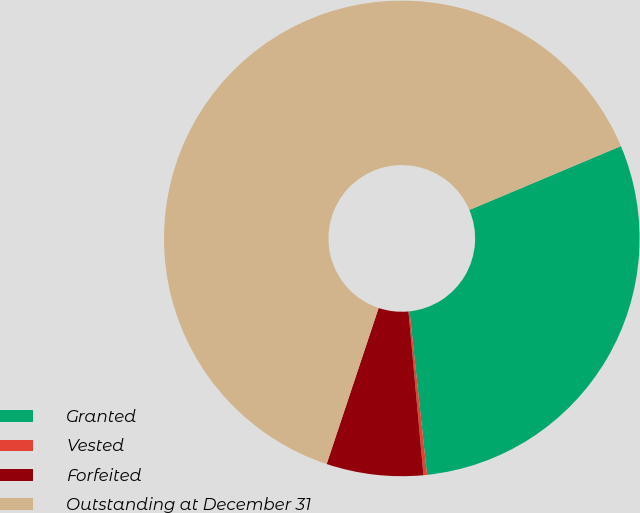Convert chart to OTSL. <chart><loc_0><loc_0><loc_500><loc_500><pie_chart><fcel>Granted<fcel>Vested<fcel>Forfeited<fcel>Outstanding at December 31<nl><fcel>29.65%<fcel>0.24%<fcel>6.57%<fcel>63.53%<nl></chart> 